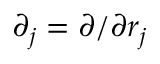Convert formula to latex. <formula><loc_0><loc_0><loc_500><loc_500>\partial _ { j } = \partial / \partial r _ { j }</formula> 